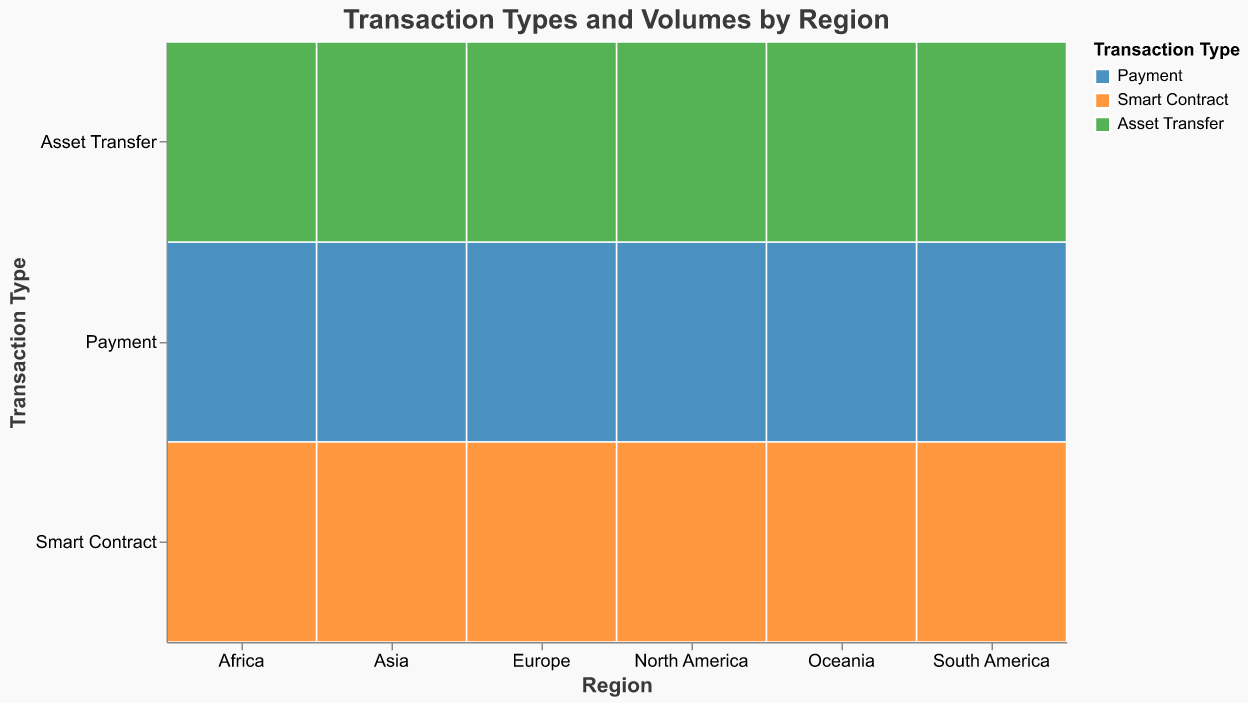What is the most common transaction type in North America? By observing the sizes of rectangles for North America, we can identify which rectangle is largest among "Payment", "Smart Contract", and "Asset Transfer". The largest rectangle represents the most common transaction type. "Payment" has the largest rectangle in North America.
Answer: Payment Which region has the largest volume of Asset Transfer transactions? By comparing the sizes of rectangles for "Asset Transfer" across all regions, we can determine which region has the largest volume. Asia has the largest rectangle for Asset Transfer transactions.
Answer: Asia What is the total volume of Smart Contract transactions in Europe? Summing up the volume of Smart Contract transactions for Europe, the value is directly given as 220,000 in the dataset.
Answer: 220000 How does the volume of Payment transactions in Asia compare to North America? Payment transactions in Asia and North America can be compared by looking at the sizes of their rectangles. Asia's Payment rectangle is larger than North America's, indicating a higher transaction volume. Specifically, Asia has 520,000 and North America has 450,000.
Answer: Asia > North America Which region has the lowest total transaction volume across all types? By summing the volumes of all transaction types for each region, we find the region with the smallest total volume. Oceania has the lowest total transaction volume.
Answer: Oceania What is the combined volume of Payment and Smart Contract transactions in South America? Adding the volumes of Payment and Smart Contract transactions in South America: 210,000 (Payment) + 90,000 (Smart Contract) = 300,000.
Answer: 300000 How does the volume of Smart Contract transactions in Africa compare to Oceania? By looking at the sizes of Smart Contract rectangles in Africa and Oceania, we can compare their volumes. Africa's Smart Contract transactions have a slight edge over Oceania's, which are 50,000 and 40,000 respectively.
Answer: Africa > Oceania What is the visual color representation for Asset Transfer transactions in the plot? The color used to represent Asset Transfer transactions can be determined by observing the color of all rectangles marked as "Asset Transfer." The rectangles for Asset Transfer are green.
Answer: Green Which transaction type has the widest rectangular area across all regions? By identifying the transaction type with the most consistent large rectangle sizes across all regions, we can determine the type with the widest area. Payment transactions generally have the widest rectangular areas.
Answer: Payment What is the total volume for transactions in Africa? Summing up all transaction types for Africa: 120,000 (Payment) + 50,000 (Smart Contract) + 80,000 (Asset Transfer) = 250,000.
Answer: 250000 